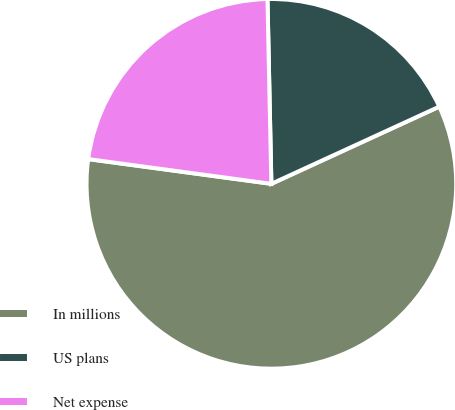Convert chart. <chart><loc_0><loc_0><loc_500><loc_500><pie_chart><fcel>In millions<fcel>US plans<fcel>Net expense<nl><fcel>59.0%<fcel>18.48%<fcel>22.53%<nl></chart> 